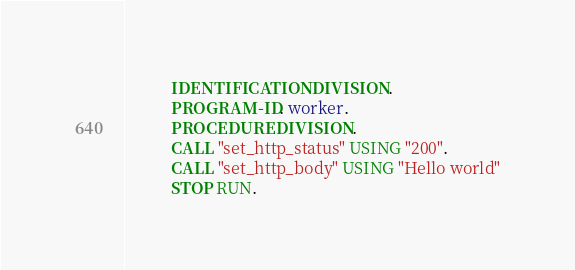<code> <loc_0><loc_0><loc_500><loc_500><_COBOL_>           IDENTIFICATION DIVISION.
           PROGRAM-ID. worker.
           PROCEDURE DIVISION.
           CALL "set_http_status" USING "200".
           CALL "set_http_body" USING "Hello world"
           STOP RUN.
</code> 